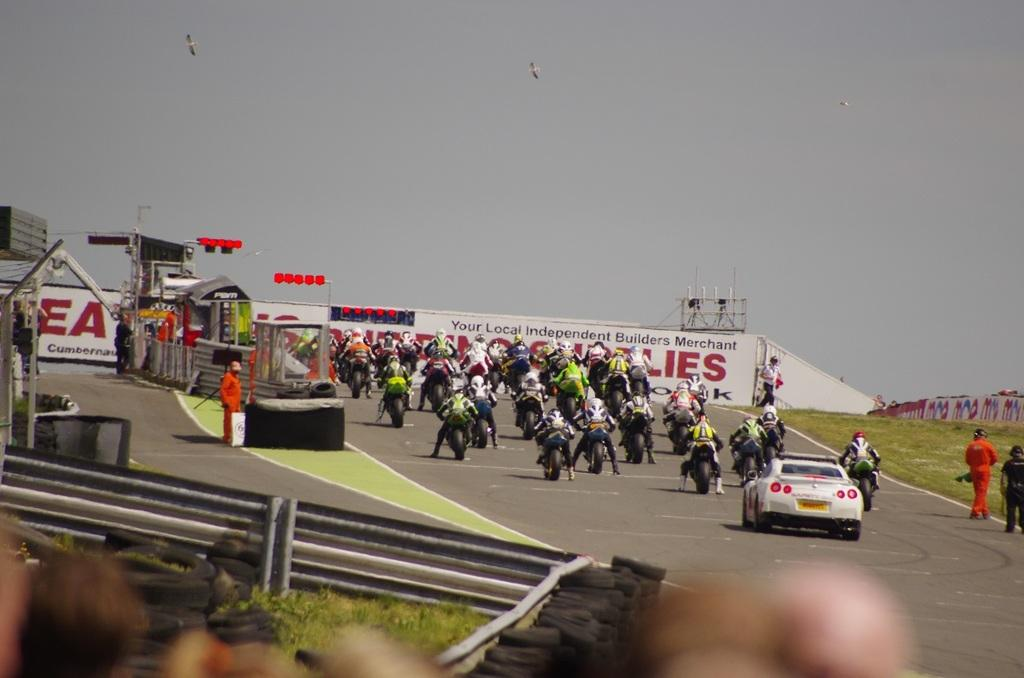<image>
Give a short and clear explanation of the subsequent image. Bikers heading towards a wall that says "your local independent builders merchant". 